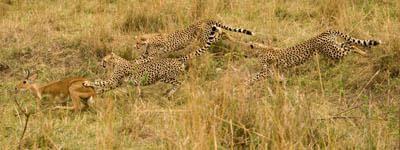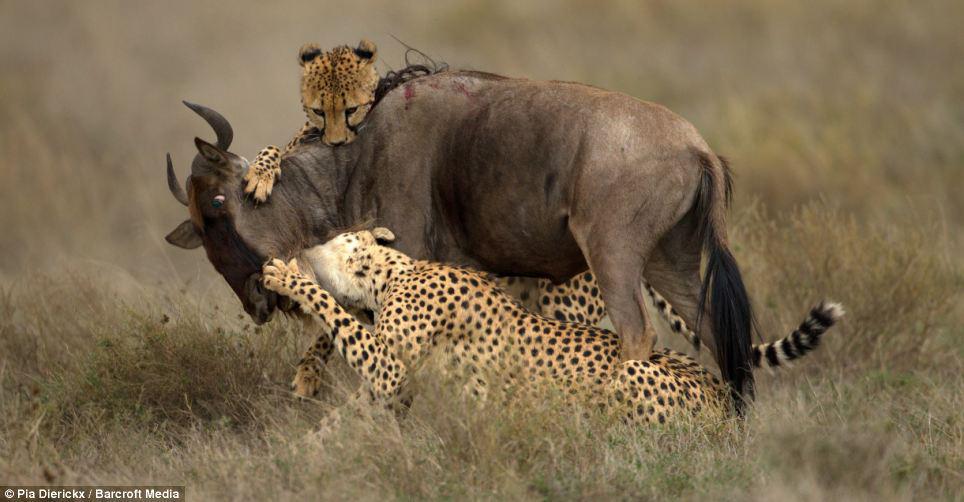The first image is the image on the left, the second image is the image on the right. For the images shown, is this caption "there is a single cheetah chasing a deer" true? Answer yes or no. No. The first image is the image on the left, the second image is the image on the right. For the images shown, is this caption "Multiple cheetahs are bounding leftward to attack a gazelle in one image." true? Answer yes or no. Yes. 